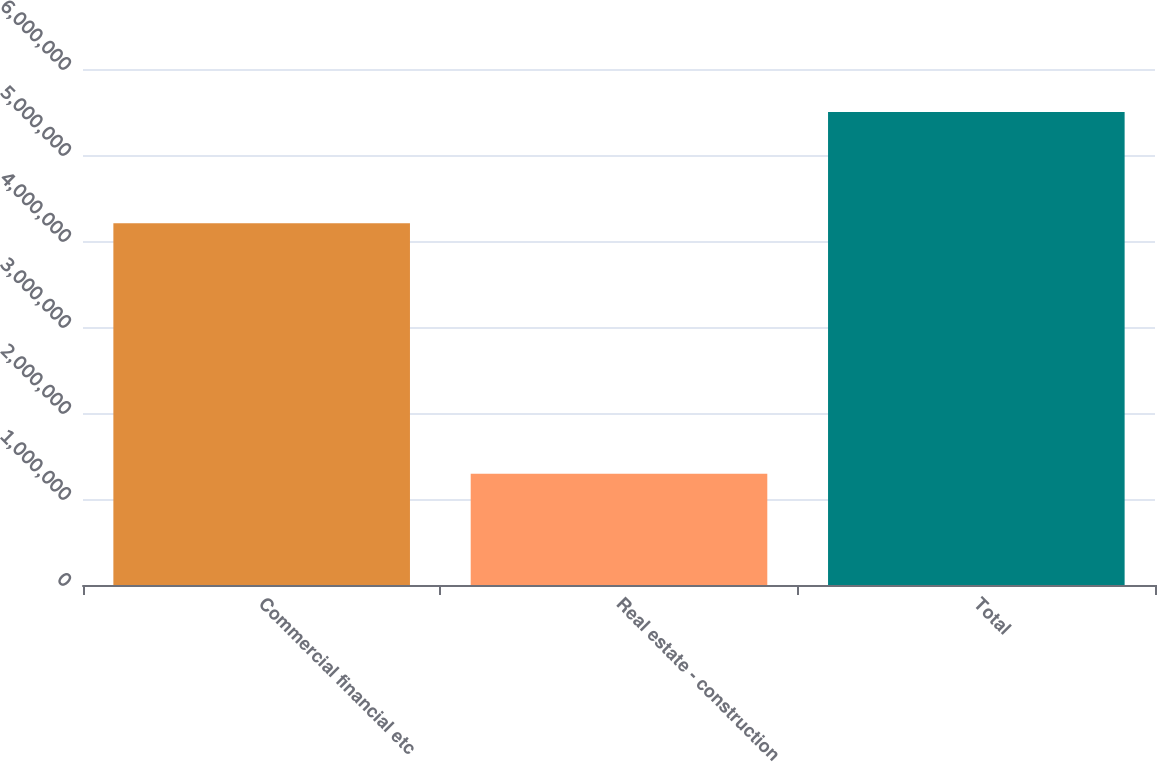<chart> <loc_0><loc_0><loc_500><loc_500><bar_chart><fcel>Commercial financial etc<fcel>Real estate - construction<fcel>Total<nl><fcel>4.20696e+06<fcel>1.29435e+06<fcel>5.5013e+06<nl></chart> 